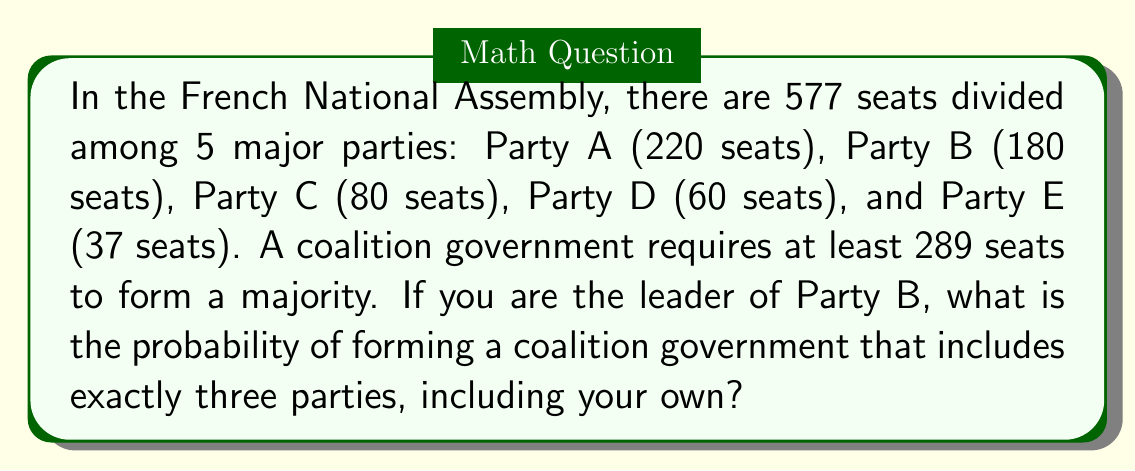Teach me how to tackle this problem. Let's approach this step-by-step:

1) First, we need to determine how many combinations of three parties (including Party B) can form a majority coalition.

2) The possible combinations are:
   - B + A + C
   - B + A + D
   - B + A + E
   - B + C + D

3) Let's check if each combination has at least 289 seats:
   - B + A + C: 180 + 220 + 80 = 480 ✓
   - B + A + D: 180 + 220 + 60 = 460 ✓
   - B + A + E: 180 + 220 + 37 = 437 ✓
   - B + C + D: 180 + 80 + 60 = 320 ✓

4) All four combinations can form a majority coalition.

5) Now, we need to calculate the total number of possible three-party coalitions including Party B:

   $$\binom{4}{2} = \frac{4!}{2!(4-2)!} = \frac{4 \cdot 3}{2 \cdot 1} = 6$$

6) The probability is therefore:

   $$P(\text{forming a three-party majority coalition}) = \frac{\text{favorable outcomes}}{\text{total possible outcomes}} = \frac{4}{6} = \frac{2}{3}$$
Answer: $\frac{2}{3}$ 